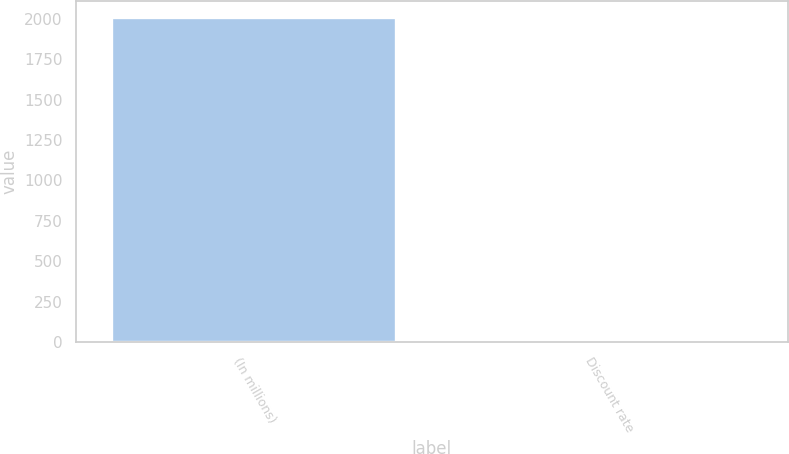Convert chart to OTSL. <chart><loc_0><loc_0><loc_500><loc_500><bar_chart><fcel>(In millions)<fcel>Discount rate<nl><fcel>2012<fcel>4.88<nl></chart> 